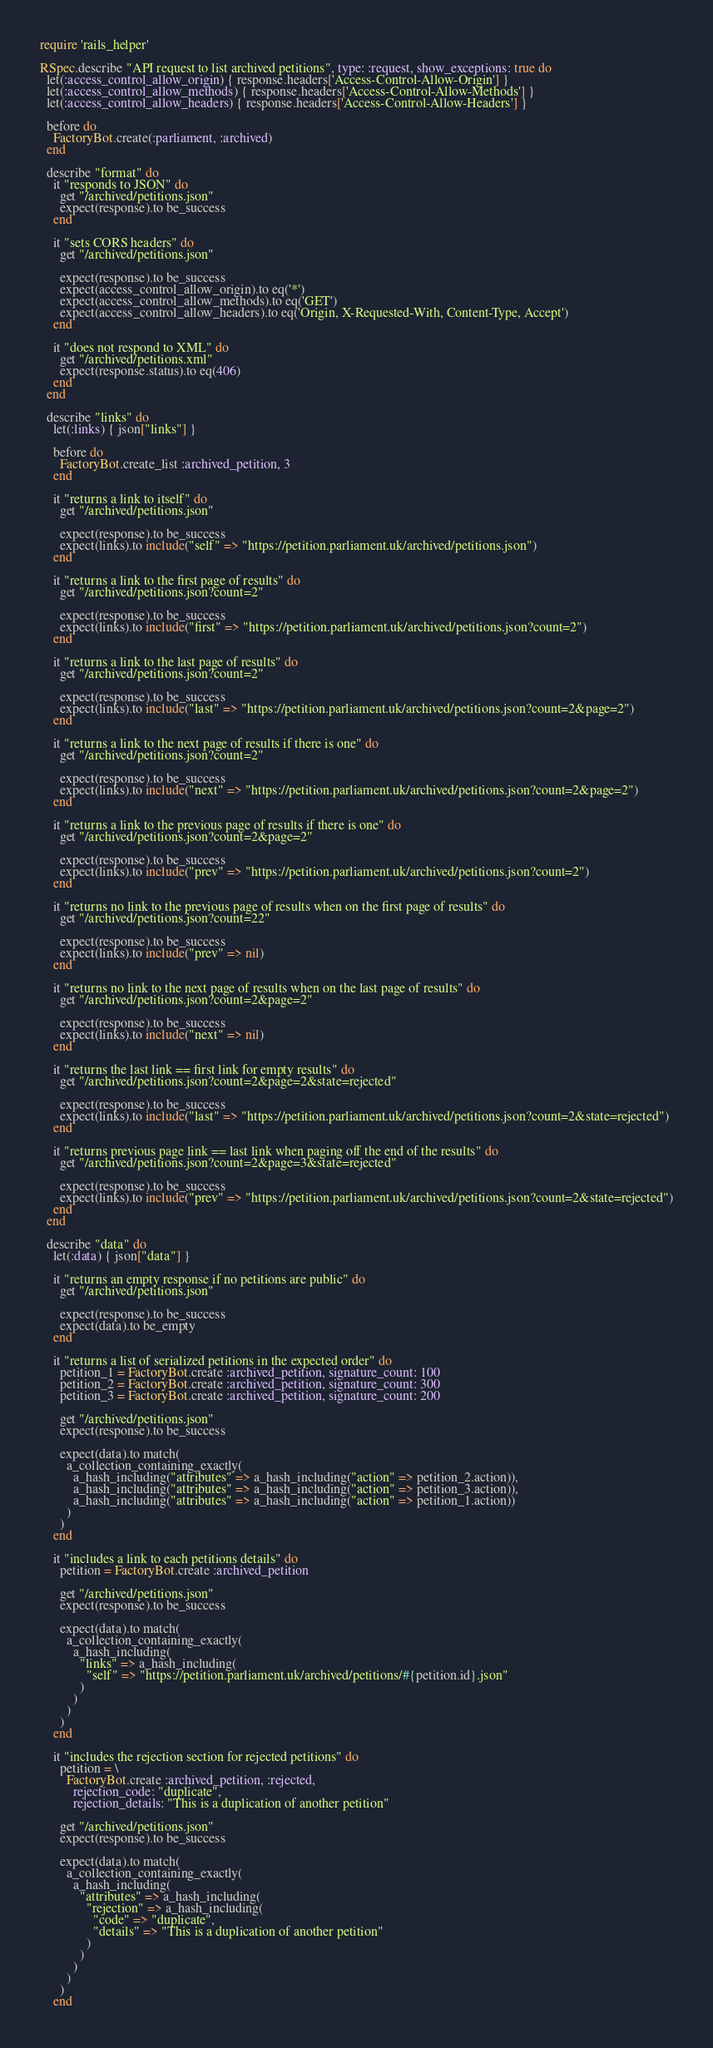Convert code to text. <code><loc_0><loc_0><loc_500><loc_500><_Ruby_>require 'rails_helper'

RSpec.describe "API request to list archived petitions", type: :request, show_exceptions: true do
  let(:access_control_allow_origin) { response.headers['Access-Control-Allow-Origin'] }
  let(:access_control_allow_methods) { response.headers['Access-Control-Allow-Methods'] }
  let(:access_control_allow_headers) { response.headers['Access-Control-Allow-Headers'] }

  before do
    FactoryBot.create(:parliament, :archived)
  end

  describe "format" do
    it "responds to JSON" do
      get "/archived/petitions.json"
      expect(response).to be_success
    end

    it "sets CORS headers" do
      get "/archived/petitions.json"

      expect(response).to be_success
      expect(access_control_allow_origin).to eq('*')
      expect(access_control_allow_methods).to eq('GET')
      expect(access_control_allow_headers).to eq('Origin, X-Requested-With, Content-Type, Accept')
    end

    it "does not respond to XML" do
      get "/archived/petitions.xml"
      expect(response.status).to eq(406)
    end
  end

  describe "links" do
    let(:links) { json["links"] }

    before do
      FactoryBot.create_list :archived_petition, 3
    end

    it "returns a link to itself" do
      get "/archived/petitions.json"

      expect(response).to be_success
      expect(links).to include("self" => "https://petition.parliament.uk/archived/petitions.json")
    end

    it "returns a link to the first page of results" do
      get "/archived/petitions.json?count=2"

      expect(response).to be_success
      expect(links).to include("first" => "https://petition.parliament.uk/archived/petitions.json?count=2")
    end

    it "returns a link to the last page of results" do
      get "/archived/petitions.json?count=2"

      expect(response).to be_success
      expect(links).to include("last" => "https://petition.parliament.uk/archived/petitions.json?count=2&page=2")
    end

    it "returns a link to the next page of results if there is one" do
      get "/archived/petitions.json?count=2"

      expect(response).to be_success
      expect(links).to include("next" => "https://petition.parliament.uk/archived/petitions.json?count=2&page=2")
    end

    it "returns a link to the previous page of results if there is one" do
      get "/archived/petitions.json?count=2&page=2"

      expect(response).to be_success
      expect(links).to include("prev" => "https://petition.parliament.uk/archived/petitions.json?count=2")
    end

    it "returns no link to the previous page of results when on the first page of results" do
      get "/archived/petitions.json?count=22"

      expect(response).to be_success
      expect(links).to include("prev" => nil)
    end

    it "returns no link to the next page of results when on the last page of results" do
      get "/archived/petitions.json?count=2&page=2"

      expect(response).to be_success
      expect(links).to include("next" => nil)
    end

    it "returns the last link == first link for empty results" do
      get "/archived/petitions.json?count=2&page=2&state=rejected"

      expect(response).to be_success
      expect(links).to include("last" => "https://petition.parliament.uk/archived/petitions.json?count=2&state=rejected")
    end

    it "returns previous page link == last link when paging off the end of the results" do
      get "/archived/petitions.json?count=2&page=3&state=rejected"

      expect(response).to be_success
      expect(links).to include("prev" => "https://petition.parliament.uk/archived/petitions.json?count=2&state=rejected")
    end
  end

  describe "data" do
    let(:data) { json["data"] }

    it "returns an empty response if no petitions are public" do
      get "/archived/petitions.json"

      expect(response).to be_success
      expect(data).to be_empty
    end

    it "returns a list of serialized petitions in the expected order" do
      petition_1 = FactoryBot.create :archived_petition, signature_count: 100
      petition_2 = FactoryBot.create :archived_petition, signature_count: 300
      petition_3 = FactoryBot.create :archived_petition, signature_count: 200

      get "/archived/petitions.json"
      expect(response).to be_success

      expect(data).to match(
        a_collection_containing_exactly(
          a_hash_including("attributes" => a_hash_including("action" => petition_2.action)),
          a_hash_including("attributes" => a_hash_including("action" => petition_3.action)),
          a_hash_including("attributes" => a_hash_including("action" => petition_1.action))
        )
      )
    end

    it "includes a link to each petitions details" do
      petition = FactoryBot.create :archived_petition

      get "/archived/petitions.json"
      expect(response).to be_success

      expect(data).to match(
        a_collection_containing_exactly(
          a_hash_including(
            "links" => a_hash_including(
              "self" => "https://petition.parliament.uk/archived/petitions/#{petition.id}.json"
            )
          )
        )
      )
    end

    it "includes the rejection section for rejected petitions" do
      petition = \
        FactoryBot.create :archived_petition, :rejected,
          rejection_code: "duplicate",
          rejection_details: "This is a duplication of another petition"

      get "/archived/petitions.json"
      expect(response).to be_success

      expect(data).to match(
        a_collection_containing_exactly(
          a_hash_including(
            "attributes" => a_hash_including(
              "rejection" => a_hash_including(
                "code" => "duplicate",
                "details" => "This is a duplication of another petition"
              )
            )
          )
        )
      )
    end
</code> 